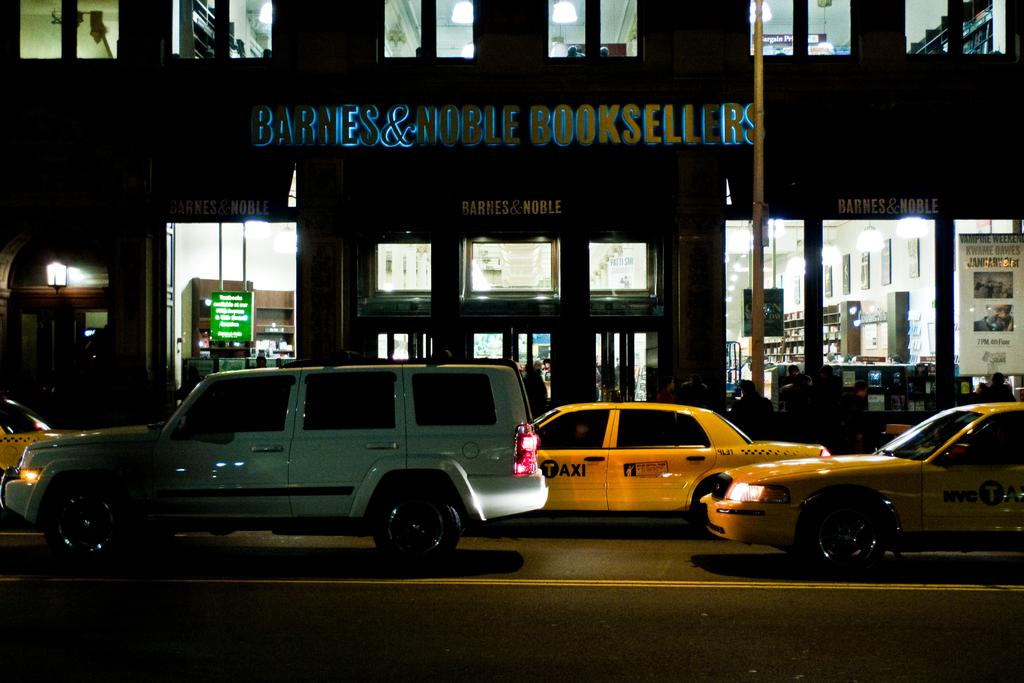<image>
Offer a succinct explanation of the picture presented. Cars driving in front of a store that says Barnes and Nobles Booksellers. 